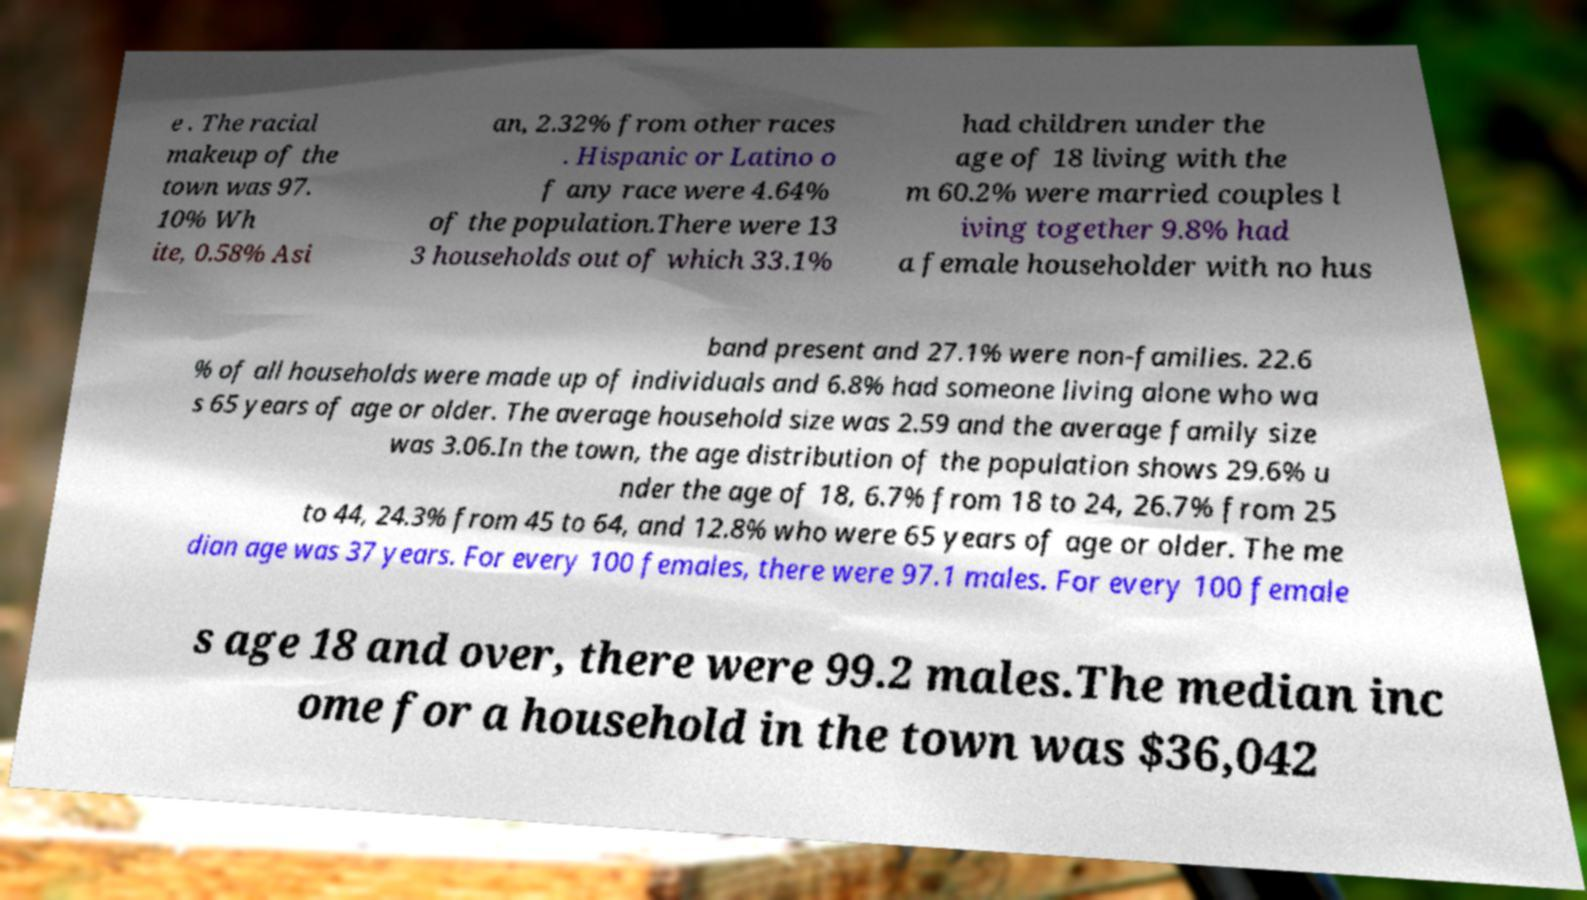Could you assist in decoding the text presented in this image and type it out clearly? e . The racial makeup of the town was 97. 10% Wh ite, 0.58% Asi an, 2.32% from other races . Hispanic or Latino o f any race were 4.64% of the population.There were 13 3 households out of which 33.1% had children under the age of 18 living with the m 60.2% were married couples l iving together 9.8% had a female householder with no hus band present and 27.1% were non-families. 22.6 % of all households were made up of individuals and 6.8% had someone living alone who wa s 65 years of age or older. The average household size was 2.59 and the average family size was 3.06.In the town, the age distribution of the population shows 29.6% u nder the age of 18, 6.7% from 18 to 24, 26.7% from 25 to 44, 24.3% from 45 to 64, and 12.8% who were 65 years of age or older. The me dian age was 37 years. For every 100 females, there were 97.1 males. For every 100 female s age 18 and over, there were 99.2 males.The median inc ome for a household in the town was $36,042 